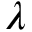Convert formula to latex. <formula><loc_0><loc_0><loc_500><loc_500>\lambda</formula> 